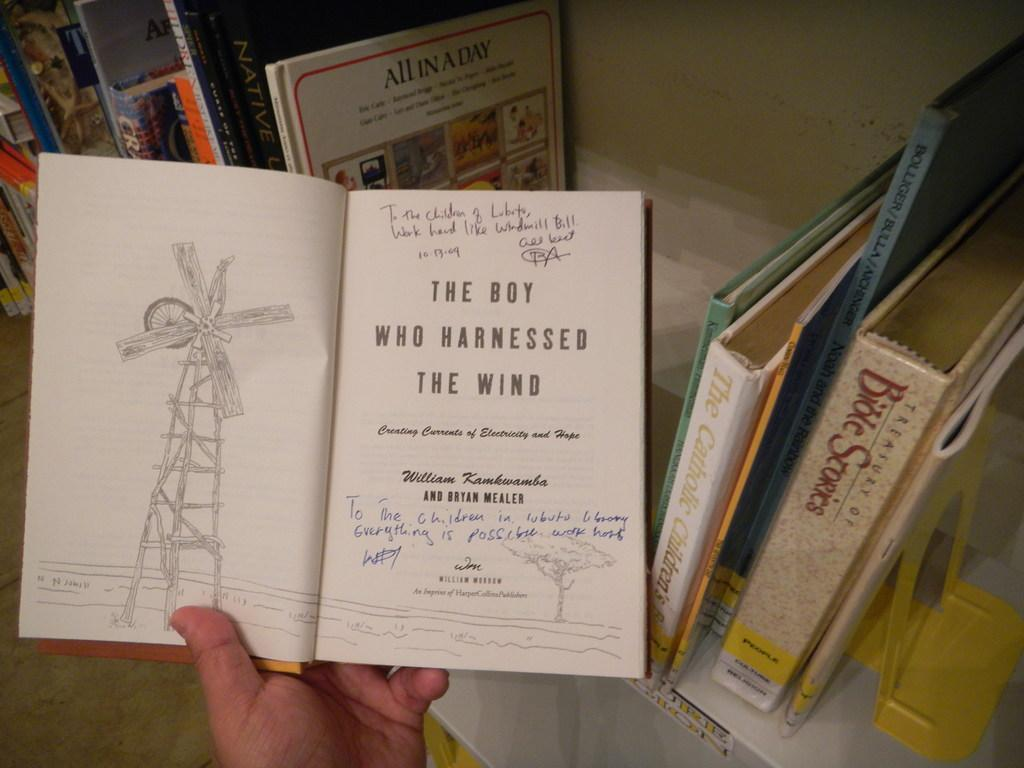<image>
Describe the image concisely. Hand is holding a book called the boy who harnessed the wind 